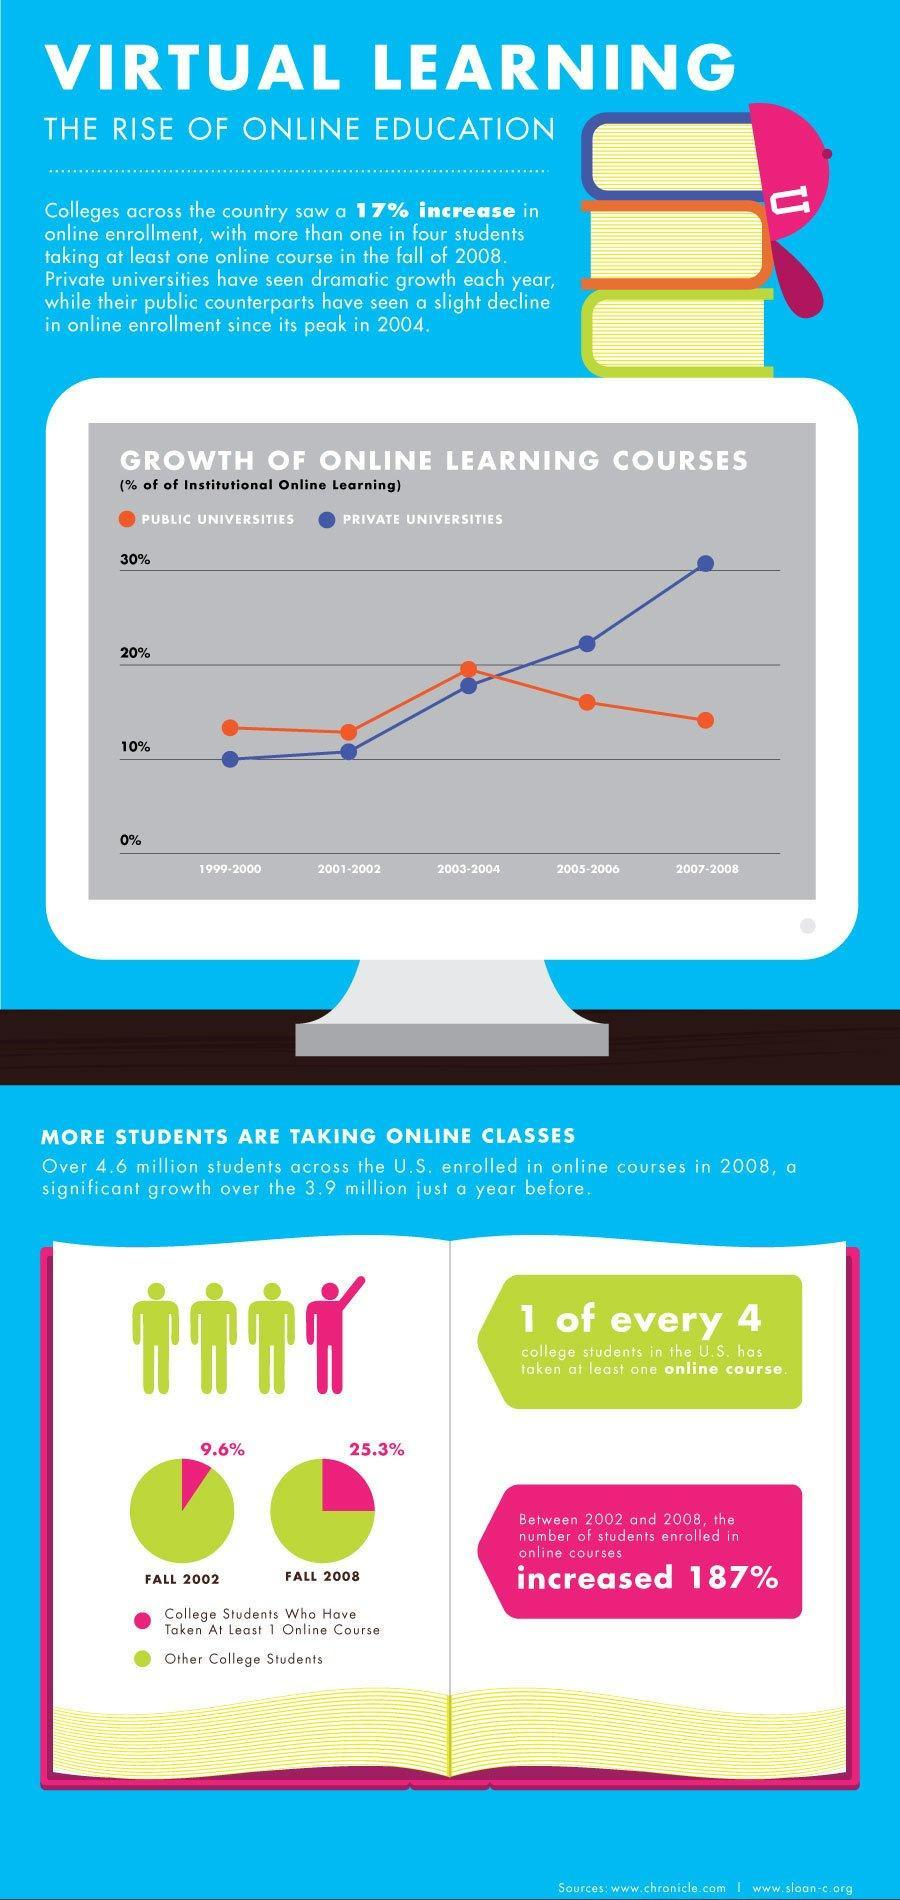Which type of universities has seen less than 20% of institutional online learning during 2005-2006?
Answer the question with a short phrase. PUBLIC UNIVERSITIES Which type of universities has seen more than 30% of institutional online learning during 2007-2008? PRIVATE UNIVERSITIES What percentage of college students in the U.S. have taken at least one online course during fall 2008? 25.3% What percentage of college students in the U.S. have taken at least one online course during fall 2002? 9.6% 